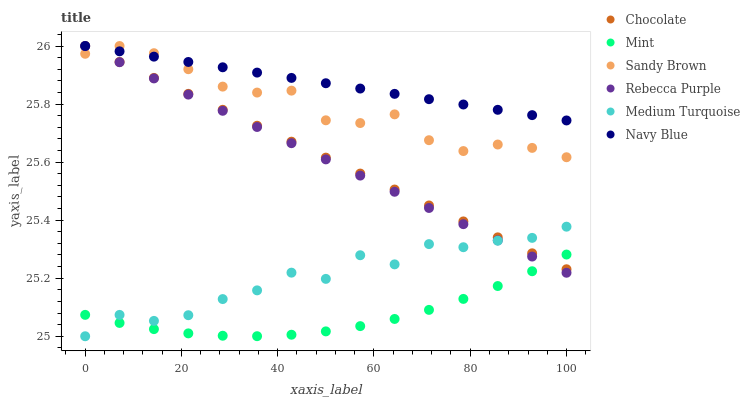Does Mint have the minimum area under the curve?
Answer yes or no. Yes. Does Navy Blue have the maximum area under the curve?
Answer yes or no. Yes. Does Chocolate have the minimum area under the curve?
Answer yes or no. No. Does Chocolate have the maximum area under the curve?
Answer yes or no. No. Is Chocolate the smoothest?
Answer yes or no. Yes. Is Medium Turquoise the roughest?
Answer yes or no. Yes. Is Rebecca Purple the smoothest?
Answer yes or no. No. Is Rebecca Purple the roughest?
Answer yes or no. No. Does Medium Turquoise have the lowest value?
Answer yes or no. Yes. Does Chocolate have the lowest value?
Answer yes or no. No. Does Sandy Brown have the highest value?
Answer yes or no. Yes. Does Medium Turquoise have the highest value?
Answer yes or no. No. Is Medium Turquoise less than Sandy Brown?
Answer yes or no. Yes. Is Navy Blue greater than Medium Turquoise?
Answer yes or no. Yes. Does Sandy Brown intersect Rebecca Purple?
Answer yes or no. Yes. Is Sandy Brown less than Rebecca Purple?
Answer yes or no. No. Is Sandy Brown greater than Rebecca Purple?
Answer yes or no. No. Does Medium Turquoise intersect Sandy Brown?
Answer yes or no. No. 